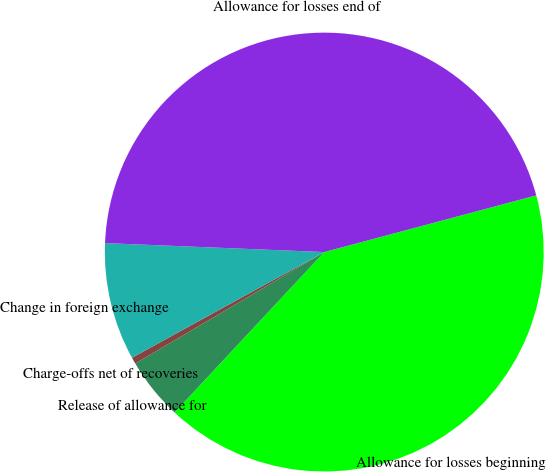Convert chart to OTSL. <chart><loc_0><loc_0><loc_500><loc_500><pie_chart><fcel>Allowance for losses beginning<fcel>Release of allowance for<fcel>Charge-offs net of recoveries<fcel>Change in foreign exchange<fcel>Allowance for losses end of<nl><fcel>41.11%<fcel>4.57%<fcel>0.48%<fcel>8.65%<fcel>45.19%<nl></chart> 